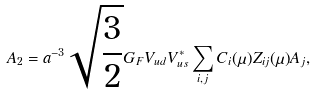Convert formula to latex. <formula><loc_0><loc_0><loc_500><loc_500>A _ { 2 } = a ^ { - 3 } \sqrt { \frac { 3 } { 2 } } G _ { F } V _ { u d } V ^ { * } _ { u s } \sum _ { i , j } C _ { i } ( \mu ) Z _ { i j } ( \mu ) A _ { j } ,</formula> 